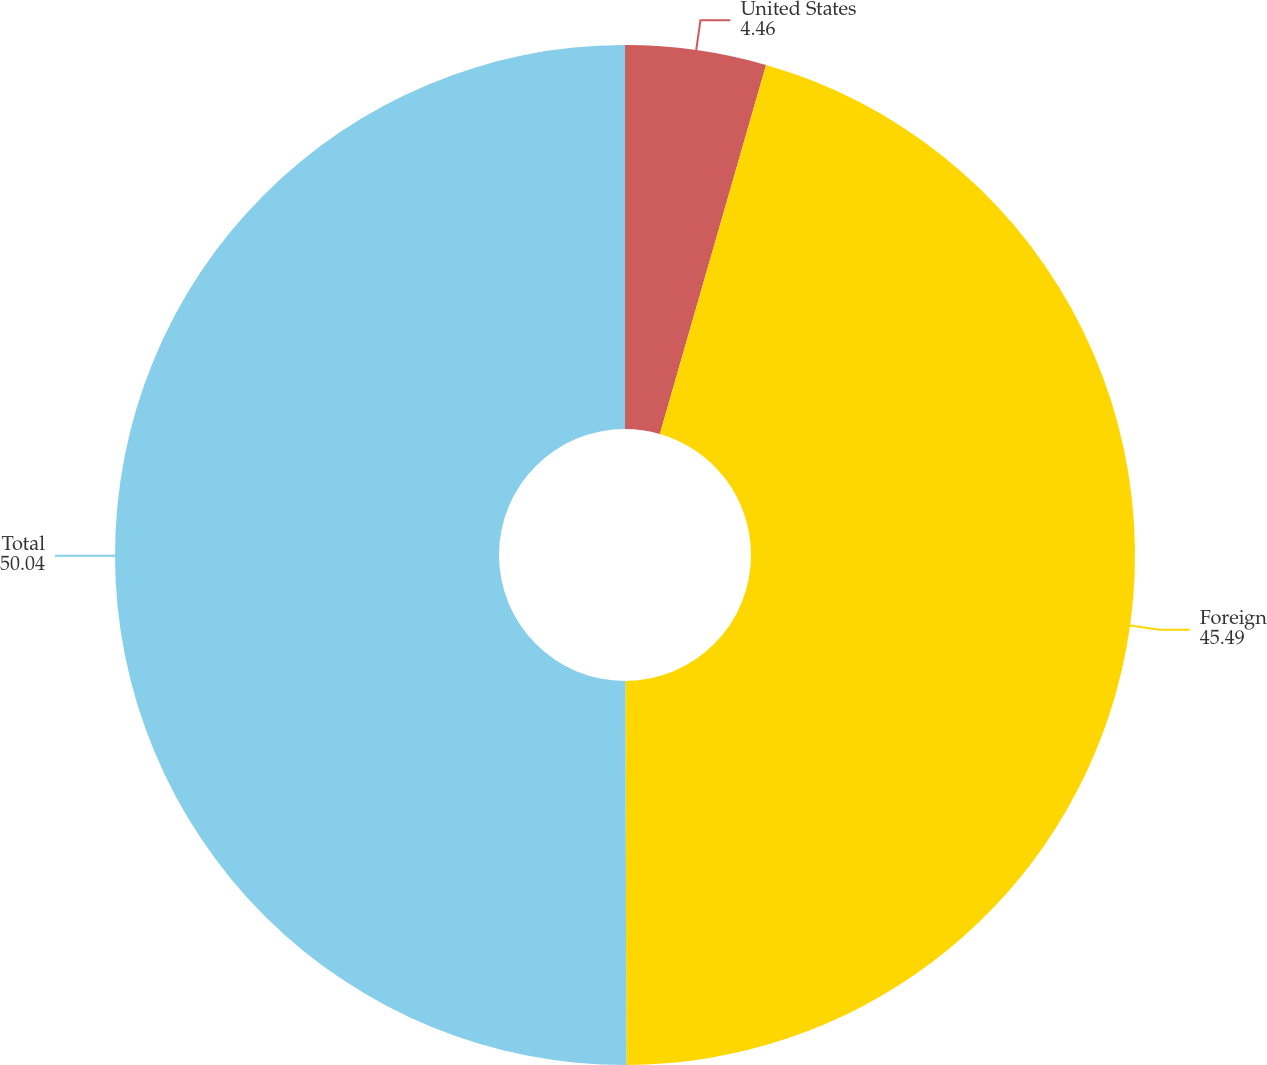Convert chart to OTSL. <chart><loc_0><loc_0><loc_500><loc_500><pie_chart><fcel>United States<fcel>Foreign<fcel>Total<nl><fcel>4.46%<fcel>45.49%<fcel>50.04%<nl></chart> 